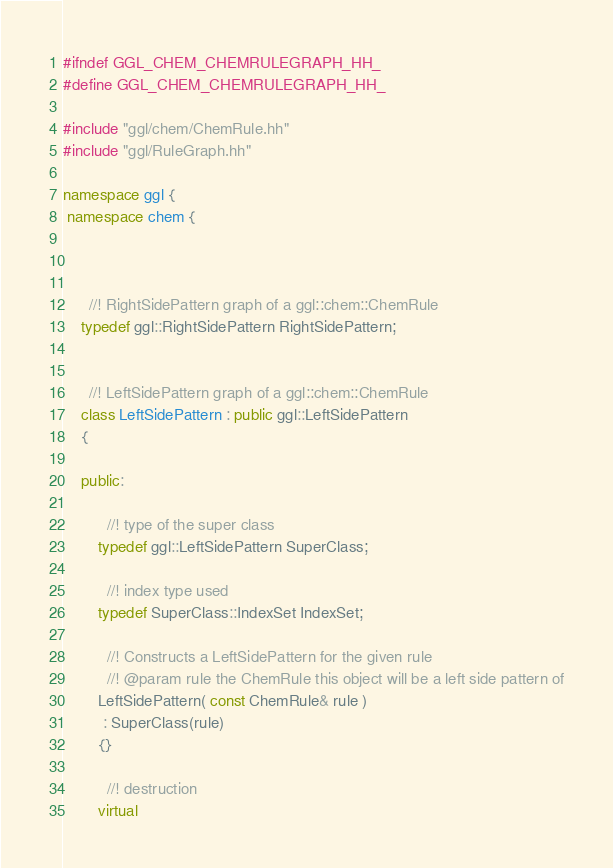<code> <loc_0><loc_0><loc_500><loc_500><_C++_>#ifndef GGL_CHEM_CHEMRULEGRAPH_HH_
#define GGL_CHEM_CHEMRULEGRAPH_HH_

#include "ggl/chem/ChemRule.hh"
#include "ggl/RuleGraph.hh"

namespace ggl {
 namespace chem {
 
 
 	
 	  //! RightSidePattern graph of a ggl::chem::ChemRule
 	typedef ggl::RightSidePattern RightSidePattern;
 	
 	
 	  //! LeftSidePattern graph of a ggl::chem::ChemRule
 	class LeftSidePattern : public ggl::LeftSidePattern
 	{

 	public:

 		  //! type of the super class
 		typedef ggl::LeftSidePattern SuperClass;

 		  //! index type used
		typedef SuperClass::IndexSet IndexSet;

		  //! Constructs a LeftSidePattern for the given rule
		  //! @param rule the ChemRule this object will be a left side pattern of
		LeftSidePattern( const ChemRule& rule )
		 : SuperClass(rule)
		{}

		  //! destruction
		virtual</code> 